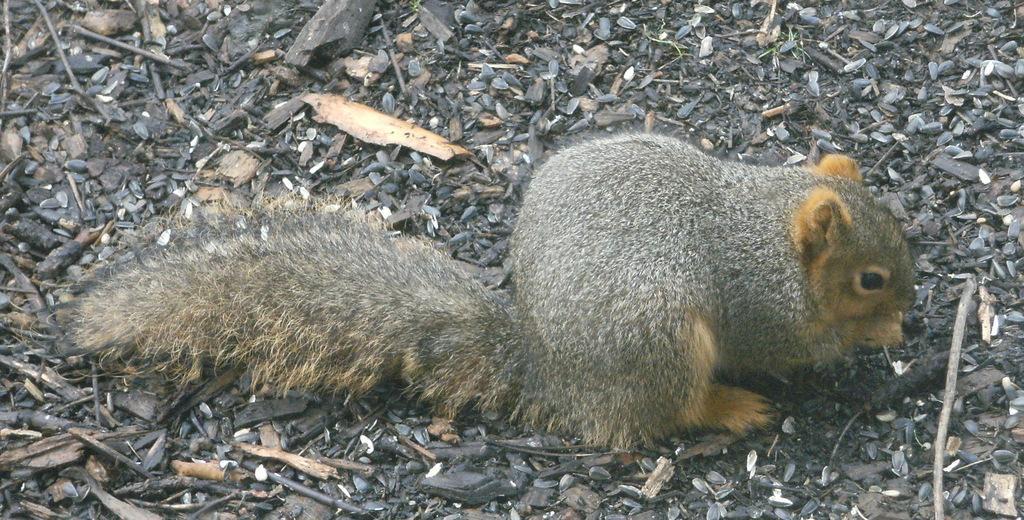Can you describe this image briefly? In this picture we can see squirrel, seeds and wooden objects. 